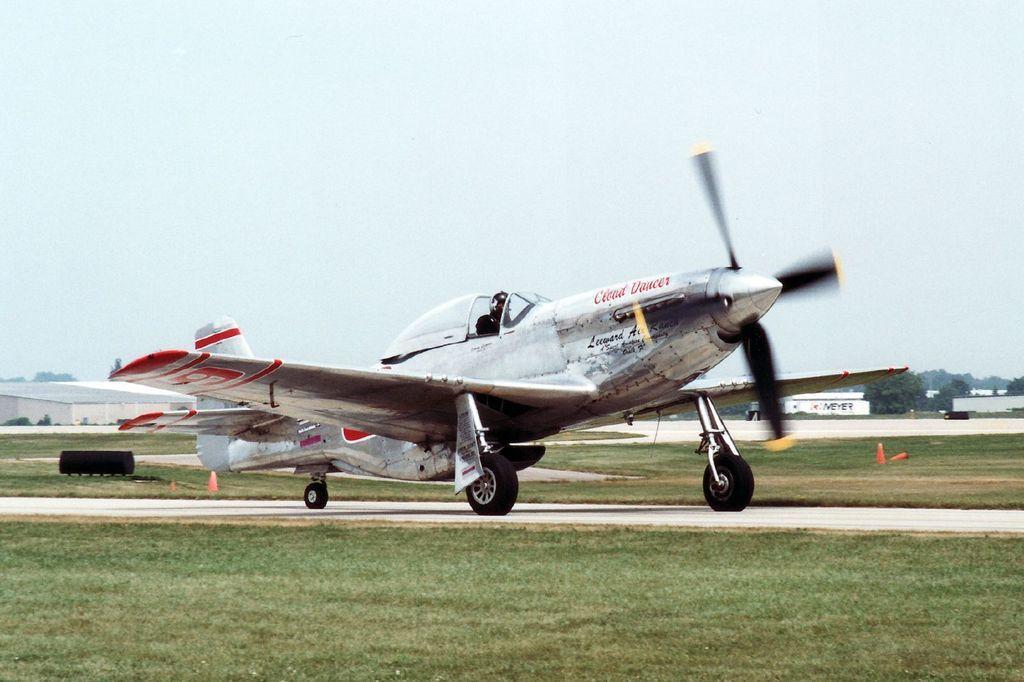Describe this image in one or two sentences. In this image, we can see an aircraft on the runway. Here we can see grass, traffic cones and black color objects. Background we can see so many houses, trees and sky. 